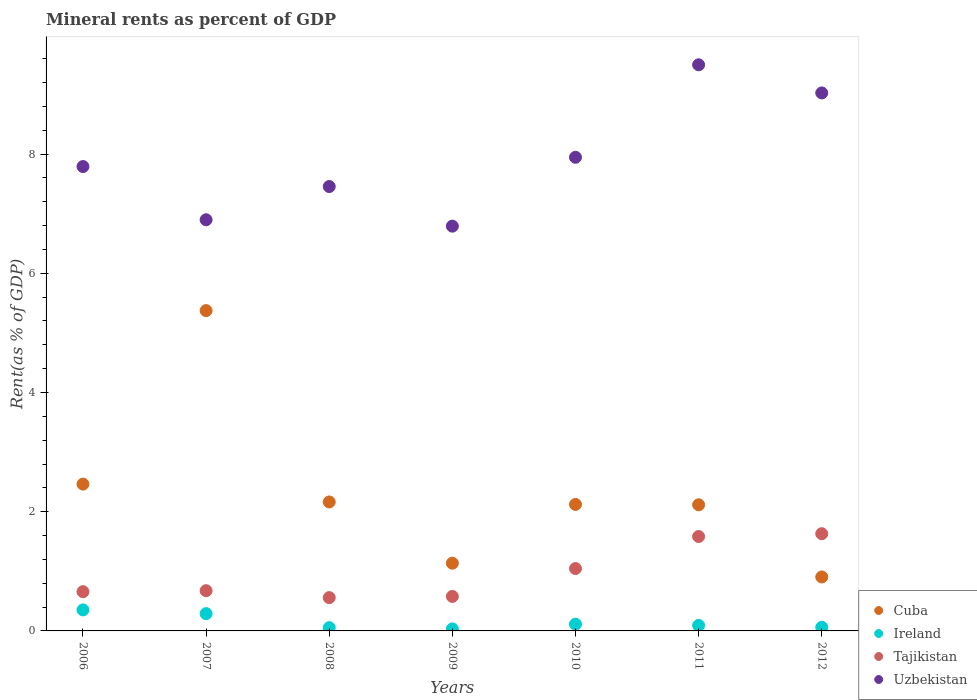What is the mineral rent in Tajikistan in 2006?
Your answer should be very brief. 0.66. Across all years, what is the maximum mineral rent in Uzbekistan?
Keep it short and to the point. 9.5. Across all years, what is the minimum mineral rent in Cuba?
Offer a terse response. 0.91. In which year was the mineral rent in Ireland minimum?
Offer a very short reply. 2009. What is the total mineral rent in Ireland in the graph?
Your answer should be very brief. 1. What is the difference between the mineral rent in Uzbekistan in 2010 and that in 2012?
Ensure brevity in your answer.  -1.08. What is the difference between the mineral rent in Uzbekistan in 2006 and the mineral rent in Cuba in 2010?
Your response must be concise. 5.67. What is the average mineral rent in Cuba per year?
Ensure brevity in your answer.  2.33. In the year 2009, what is the difference between the mineral rent in Ireland and mineral rent in Uzbekistan?
Your answer should be very brief. -6.76. What is the ratio of the mineral rent in Uzbekistan in 2010 to that in 2012?
Keep it short and to the point. 0.88. Is the difference between the mineral rent in Ireland in 2006 and 2012 greater than the difference between the mineral rent in Uzbekistan in 2006 and 2012?
Your response must be concise. Yes. What is the difference between the highest and the second highest mineral rent in Uzbekistan?
Make the answer very short. 0.47. What is the difference between the highest and the lowest mineral rent in Ireland?
Keep it short and to the point. 0.32. Is the sum of the mineral rent in Uzbekistan in 2006 and 2007 greater than the maximum mineral rent in Cuba across all years?
Make the answer very short. Yes. Is it the case that in every year, the sum of the mineral rent in Ireland and mineral rent in Cuba  is greater than the sum of mineral rent in Tajikistan and mineral rent in Uzbekistan?
Make the answer very short. No. Is the mineral rent in Tajikistan strictly less than the mineral rent in Ireland over the years?
Ensure brevity in your answer.  No. How many years are there in the graph?
Your answer should be compact. 7. Are the values on the major ticks of Y-axis written in scientific E-notation?
Your answer should be compact. No. Does the graph contain grids?
Give a very brief answer. No. What is the title of the graph?
Your response must be concise. Mineral rents as percent of GDP. Does "South Africa" appear as one of the legend labels in the graph?
Give a very brief answer. No. What is the label or title of the Y-axis?
Offer a terse response. Rent(as % of GDP). What is the Rent(as % of GDP) of Cuba in 2006?
Give a very brief answer. 2.46. What is the Rent(as % of GDP) of Ireland in 2006?
Keep it short and to the point. 0.35. What is the Rent(as % of GDP) in Tajikistan in 2006?
Keep it short and to the point. 0.66. What is the Rent(as % of GDP) in Uzbekistan in 2006?
Offer a very short reply. 7.79. What is the Rent(as % of GDP) of Cuba in 2007?
Give a very brief answer. 5.37. What is the Rent(as % of GDP) of Ireland in 2007?
Provide a succinct answer. 0.29. What is the Rent(as % of GDP) of Tajikistan in 2007?
Make the answer very short. 0.67. What is the Rent(as % of GDP) of Uzbekistan in 2007?
Provide a short and direct response. 6.9. What is the Rent(as % of GDP) of Cuba in 2008?
Make the answer very short. 2.16. What is the Rent(as % of GDP) of Ireland in 2008?
Make the answer very short. 0.05. What is the Rent(as % of GDP) of Tajikistan in 2008?
Offer a terse response. 0.56. What is the Rent(as % of GDP) of Uzbekistan in 2008?
Provide a succinct answer. 7.45. What is the Rent(as % of GDP) in Cuba in 2009?
Keep it short and to the point. 1.14. What is the Rent(as % of GDP) of Ireland in 2009?
Make the answer very short. 0.03. What is the Rent(as % of GDP) in Tajikistan in 2009?
Your response must be concise. 0.58. What is the Rent(as % of GDP) in Uzbekistan in 2009?
Provide a succinct answer. 6.79. What is the Rent(as % of GDP) of Cuba in 2010?
Make the answer very short. 2.12. What is the Rent(as % of GDP) of Ireland in 2010?
Your answer should be very brief. 0.11. What is the Rent(as % of GDP) in Tajikistan in 2010?
Provide a short and direct response. 1.05. What is the Rent(as % of GDP) in Uzbekistan in 2010?
Your response must be concise. 7.95. What is the Rent(as % of GDP) in Cuba in 2011?
Your answer should be very brief. 2.12. What is the Rent(as % of GDP) of Ireland in 2011?
Your answer should be very brief. 0.09. What is the Rent(as % of GDP) in Tajikistan in 2011?
Give a very brief answer. 1.58. What is the Rent(as % of GDP) of Uzbekistan in 2011?
Ensure brevity in your answer.  9.5. What is the Rent(as % of GDP) of Cuba in 2012?
Offer a terse response. 0.91. What is the Rent(as % of GDP) of Ireland in 2012?
Give a very brief answer. 0.06. What is the Rent(as % of GDP) of Tajikistan in 2012?
Offer a terse response. 1.63. What is the Rent(as % of GDP) of Uzbekistan in 2012?
Your answer should be compact. 9.03. Across all years, what is the maximum Rent(as % of GDP) in Cuba?
Keep it short and to the point. 5.37. Across all years, what is the maximum Rent(as % of GDP) of Ireland?
Your answer should be compact. 0.35. Across all years, what is the maximum Rent(as % of GDP) of Tajikistan?
Your answer should be compact. 1.63. Across all years, what is the maximum Rent(as % of GDP) in Uzbekistan?
Ensure brevity in your answer.  9.5. Across all years, what is the minimum Rent(as % of GDP) in Cuba?
Offer a very short reply. 0.91. Across all years, what is the minimum Rent(as % of GDP) of Ireland?
Make the answer very short. 0.03. Across all years, what is the minimum Rent(as % of GDP) in Tajikistan?
Your answer should be compact. 0.56. Across all years, what is the minimum Rent(as % of GDP) in Uzbekistan?
Make the answer very short. 6.79. What is the total Rent(as % of GDP) in Cuba in the graph?
Ensure brevity in your answer.  16.28. What is the total Rent(as % of GDP) in Tajikistan in the graph?
Ensure brevity in your answer.  6.73. What is the total Rent(as % of GDP) in Uzbekistan in the graph?
Ensure brevity in your answer.  55.4. What is the difference between the Rent(as % of GDP) of Cuba in 2006 and that in 2007?
Make the answer very short. -2.91. What is the difference between the Rent(as % of GDP) in Ireland in 2006 and that in 2007?
Offer a very short reply. 0.06. What is the difference between the Rent(as % of GDP) in Tajikistan in 2006 and that in 2007?
Provide a succinct answer. -0.02. What is the difference between the Rent(as % of GDP) in Uzbekistan in 2006 and that in 2007?
Your answer should be very brief. 0.89. What is the difference between the Rent(as % of GDP) of Cuba in 2006 and that in 2008?
Your response must be concise. 0.3. What is the difference between the Rent(as % of GDP) of Ireland in 2006 and that in 2008?
Offer a terse response. 0.3. What is the difference between the Rent(as % of GDP) in Tajikistan in 2006 and that in 2008?
Make the answer very short. 0.1. What is the difference between the Rent(as % of GDP) of Uzbekistan in 2006 and that in 2008?
Your answer should be compact. 0.34. What is the difference between the Rent(as % of GDP) in Cuba in 2006 and that in 2009?
Offer a terse response. 1.33. What is the difference between the Rent(as % of GDP) in Ireland in 2006 and that in 2009?
Your answer should be very brief. 0.32. What is the difference between the Rent(as % of GDP) of Tajikistan in 2006 and that in 2009?
Your answer should be very brief. 0.08. What is the difference between the Rent(as % of GDP) in Cuba in 2006 and that in 2010?
Provide a succinct answer. 0.34. What is the difference between the Rent(as % of GDP) in Ireland in 2006 and that in 2010?
Keep it short and to the point. 0.24. What is the difference between the Rent(as % of GDP) in Tajikistan in 2006 and that in 2010?
Keep it short and to the point. -0.39. What is the difference between the Rent(as % of GDP) of Uzbekistan in 2006 and that in 2010?
Make the answer very short. -0.16. What is the difference between the Rent(as % of GDP) of Cuba in 2006 and that in 2011?
Your response must be concise. 0.35. What is the difference between the Rent(as % of GDP) in Ireland in 2006 and that in 2011?
Provide a succinct answer. 0.26. What is the difference between the Rent(as % of GDP) of Tajikistan in 2006 and that in 2011?
Offer a terse response. -0.93. What is the difference between the Rent(as % of GDP) in Uzbekistan in 2006 and that in 2011?
Offer a terse response. -1.71. What is the difference between the Rent(as % of GDP) in Cuba in 2006 and that in 2012?
Your answer should be compact. 1.56. What is the difference between the Rent(as % of GDP) in Ireland in 2006 and that in 2012?
Your answer should be very brief. 0.29. What is the difference between the Rent(as % of GDP) in Tajikistan in 2006 and that in 2012?
Keep it short and to the point. -0.97. What is the difference between the Rent(as % of GDP) of Uzbekistan in 2006 and that in 2012?
Your answer should be very brief. -1.23. What is the difference between the Rent(as % of GDP) in Cuba in 2007 and that in 2008?
Offer a terse response. 3.21. What is the difference between the Rent(as % of GDP) of Ireland in 2007 and that in 2008?
Provide a short and direct response. 0.24. What is the difference between the Rent(as % of GDP) in Tajikistan in 2007 and that in 2008?
Make the answer very short. 0.12. What is the difference between the Rent(as % of GDP) in Uzbekistan in 2007 and that in 2008?
Ensure brevity in your answer.  -0.56. What is the difference between the Rent(as % of GDP) in Cuba in 2007 and that in 2009?
Provide a short and direct response. 4.24. What is the difference between the Rent(as % of GDP) in Ireland in 2007 and that in 2009?
Your answer should be compact. 0.26. What is the difference between the Rent(as % of GDP) of Tajikistan in 2007 and that in 2009?
Provide a succinct answer. 0.1. What is the difference between the Rent(as % of GDP) in Uzbekistan in 2007 and that in 2009?
Offer a terse response. 0.11. What is the difference between the Rent(as % of GDP) of Cuba in 2007 and that in 2010?
Your answer should be compact. 3.25. What is the difference between the Rent(as % of GDP) in Ireland in 2007 and that in 2010?
Provide a succinct answer. 0.18. What is the difference between the Rent(as % of GDP) in Tajikistan in 2007 and that in 2010?
Your response must be concise. -0.37. What is the difference between the Rent(as % of GDP) of Uzbekistan in 2007 and that in 2010?
Keep it short and to the point. -1.05. What is the difference between the Rent(as % of GDP) in Cuba in 2007 and that in 2011?
Ensure brevity in your answer.  3.26. What is the difference between the Rent(as % of GDP) of Ireland in 2007 and that in 2011?
Provide a short and direct response. 0.2. What is the difference between the Rent(as % of GDP) in Tajikistan in 2007 and that in 2011?
Your response must be concise. -0.91. What is the difference between the Rent(as % of GDP) of Uzbekistan in 2007 and that in 2011?
Provide a succinct answer. -2.6. What is the difference between the Rent(as % of GDP) in Cuba in 2007 and that in 2012?
Offer a very short reply. 4.47. What is the difference between the Rent(as % of GDP) of Ireland in 2007 and that in 2012?
Provide a short and direct response. 0.23. What is the difference between the Rent(as % of GDP) in Tajikistan in 2007 and that in 2012?
Keep it short and to the point. -0.96. What is the difference between the Rent(as % of GDP) of Uzbekistan in 2007 and that in 2012?
Your answer should be very brief. -2.13. What is the difference between the Rent(as % of GDP) in Cuba in 2008 and that in 2009?
Provide a short and direct response. 1.03. What is the difference between the Rent(as % of GDP) of Ireland in 2008 and that in 2009?
Offer a very short reply. 0.02. What is the difference between the Rent(as % of GDP) of Tajikistan in 2008 and that in 2009?
Provide a short and direct response. -0.02. What is the difference between the Rent(as % of GDP) of Uzbekistan in 2008 and that in 2009?
Offer a terse response. 0.66. What is the difference between the Rent(as % of GDP) in Cuba in 2008 and that in 2010?
Offer a very short reply. 0.04. What is the difference between the Rent(as % of GDP) of Ireland in 2008 and that in 2010?
Offer a very short reply. -0.06. What is the difference between the Rent(as % of GDP) of Tajikistan in 2008 and that in 2010?
Ensure brevity in your answer.  -0.49. What is the difference between the Rent(as % of GDP) of Uzbekistan in 2008 and that in 2010?
Your answer should be very brief. -0.49. What is the difference between the Rent(as % of GDP) in Cuba in 2008 and that in 2011?
Your answer should be very brief. 0.05. What is the difference between the Rent(as % of GDP) of Ireland in 2008 and that in 2011?
Your response must be concise. -0.04. What is the difference between the Rent(as % of GDP) in Tajikistan in 2008 and that in 2011?
Provide a short and direct response. -1.03. What is the difference between the Rent(as % of GDP) of Uzbekistan in 2008 and that in 2011?
Offer a terse response. -2.04. What is the difference between the Rent(as % of GDP) of Cuba in 2008 and that in 2012?
Your answer should be very brief. 1.26. What is the difference between the Rent(as % of GDP) in Ireland in 2008 and that in 2012?
Keep it short and to the point. -0.01. What is the difference between the Rent(as % of GDP) in Tajikistan in 2008 and that in 2012?
Provide a short and direct response. -1.07. What is the difference between the Rent(as % of GDP) of Uzbekistan in 2008 and that in 2012?
Offer a terse response. -1.57. What is the difference between the Rent(as % of GDP) in Cuba in 2009 and that in 2010?
Offer a terse response. -0.99. What is the difference between the Rent(as % of GDP) in Ireland in 2009 and that in 2010?
Offer a very short reply. -0.08. What is the difference between the Rent(as % of GDP) in Tajikistan in 2009 and that in 2010?
Make the answer very short. -0.47. What is the difference between the Rent(as % of GDP) in Uzbekistan in 2009 and that in 2010?
Ensure brevity in your answer.  -1.16. What is the difference between the Rent(as % of GDP) in Cuba in 2009 and that in 2011?
Provide a short and direct response. -0.98. What is the difference between the Rent(as % of GDP) in Ireland in 2009 and that in 2011?
Offer a terse response. -0.06. What is the difference between the Rent(as % of GDP) in Tajikistan in 2009 and that in 2011?
Your answer should be compact. -1.01. What is the difference between the Rent(as % of GDP) of Uzbekistan in 2009 and that in 2011?
Give a very brief answer. -2.71. What is the difference between the Rent(as % of GDP) of Cuba in 2009 and that in 2012?
Make the answer very short. 0.23. What is the difference between the Rent(as % of GDP) of Ireland in 2009 and that in 2012?
Keep it short and to the point. -0.03. What is the difference between the Rent(as % of GDP) in Tajikistan in 2009 and that in 2012?
Offer a very short reply. -1.05. What is the difference between the Rent(as % of GDP) in Uzbekistan in 2009 and that in 2012?
Provide a succinct answer. -2.23. What is the difference between the Rent(as % of GDP) of Cuba in 2010 and that in 2011?
Provide a succinct answer. 0.01. What is the difference between the Rent(as % of GDP) in Ireland in 2010 and that in 2011?
Provide a short and direct response. 0.02. What is the difference between the Rent(as % of GDP) of Tajikistan in 2010 and that in 2011?
Your answer should be very brief. -0.54. What is the difference between the Rent(as % of GDP) of Uzbekistan in 2010 and that in 2011?
Offer a very short reply. -1.55. What is the difference between the Rent(as % of GDP) of Cuba in 2010 and that in 2012?
Your answer should be compact. 1.22. What is the difference between the Rent(as % of GDP) in Ireland in 2010 and that in 2012?
Give a very brief answer. 0.05. What is the difference between the Rent(as % of GDP) of Tajikistan in 2010 and that in 2012?
Offer a very short reply. -0.58. What is the difference between the Rent(as % of GDP) in Uzbekistan in 2010 and that in 2012?
Make the answer very short. -1.08. What is the difference between the Rent(as % of GDP) in Cuba in 2011 and that in 2012?
Make the answer very short. 1.21. What is the difference between the Rent(as % of GDP) of Ireland in 2011 and that in 2012?
Provide a succinct answer. 0.03. What is the difference between the Rent(as % of GDP) of Tajikistan in 2011 and that in 2012?
Offer a terse response. -0.05. What is the difference between the Rent(as % of GDP) in Uzbekistan in 2011 and that in 2012?
Ensure brevity in your answer.  0.47. What is the difference between the Rent(as % of GDP) of Cuba in 2006 and the Rent(as % of GDP) of Ireland in 2007?
Your response must be concise. 2.17. What is the difference between the Rent(as % of GDP) of Cuba in 2006 and the Rent(as % of GDP) of Tajikistan in 2007?
Give a very brief answer. 1.79. What is the difference between the Rent(as % of GDP) of Cuba in 2006 and the Rent(as % of GDP) of Uzbekistan in 2007?
Offer a terse response. -4.43. What is the difference between the Rent(as % of GDP) of Ireland in 2006 and the Rent(as % of GDP) of Tajikistan in 2007?
Make the answer very short. -0.32. What is the difference between the Rent(as % of GDP) of Ireland in 2006 and the Rent(as % of GDP) of Uzbekistan in 2007?
Offer a terse response. -6.55. What is the difference between the Rent(as % of GDP) of Tajikistan in 2006 and the Rent(as % of GDP) of Uzbekistan in 2007?
Provide a short and direct response. -6.24. What is the difference between the Rent(as % of GDP) of Cuba in 2006 and the Rent(as % of GDP) of Ireland in 2008?
Your response must be concise. 2.41. What is the difference between the Rent(as % of GDP) in Cuba in 2006 and the Rent(as % of GDP) in Tajikistan in 2008?
Keep it short and to the point. 1.9. What is the difference between the Rent(as % of GDP) in Cuba in 2006 and the Rent(as % of GDP) in Uzbekistan in 2008?
Your answer should be compact. -4.99. What is the difference between the Rent(as % of GDP) of Ireland in 2006 and the Rent(as % of GDP) of Tajikistan in 2008?
Ensure brevity in your answer.  -0.21. What is the difference between the Rent(as % of GDP) in Ireland in 2006 and the Rent(as % of GDP) in Uzbekistan in 2008?
Your response must be concise. -7.1. What is the difference between the Rent(as % of GDP) in Tajikistan in 2006 and the Rent(as % of GDP) in Uzbekistan in 2008?
Your answer should be compact. -6.8. What is the difference between the Rent(as % of GDP) in Cuba in 2006 and the Rent(as % of GDP) in Ireland in 2009?
Ensure brevity in your answer.  2.43. What is the difference between the Rent(as % of GDP) in Cuba in 2006 and the Rent(as % of GDP) in Tajikistan in 2009?
Keep it short and to the point. 1.88. What is the difference between the Rent(as % of GDP) of Cuba in 2006 and the Rent(as % of GDP) of Uzbekistan in 2009?
Your answer should be compact. -4.33. What is the difference between the Rent(as % of GDP) of Ireland in 2006 and the Rent(as % of GDP) of Tajikistan in 2009?
Offer a very short reply. -0.23. What is the difference between the Rent(as % of GDP) of Ireland in 2006 and the Rent(as % of GDP) of Uzbekistan in 2009?
Keep it short and to the point. -6.44. What is the difference between the Rent(as % of GDP) in Tajikistan in 2006 and the Rent(as % of GDP) in Uzbekistan in 2009?
Your response must be concise. -6.13. What is the difference between the Rent(as % of GDP) in Cuba in 2006 and the Rent(as % of GDP) in Ireland in 2010?
Your response must be concise. 2.35. What is the difference between the Rent(as % of GDP) in Cuba in 2006 and the Rent(as % of GDP) in Tajikistan in 2010?
Give a very brief answer. 1.42. What is the difference between the Rent(as % of GDP) in Cuba in 2006 and the Rent(as % of GDP) in Uzbekistan in 2010?
Offer a terse response. -5.48. What is the difference between the Rent(as % of GDP) in Ireland in 2006 and the Rent(as % of GDP) in Tajikistan in 2010?
Your answer should be compact. -0.69. What is the difference between the Rent(as % of GDP) of Ireland in 2006 and the Rent(as % of GDP) of Uzbekistan in 2010?
Your answer should be very brief. -7.59. What is the difference between the Rent(as % of GDP) of Tajikistan in 2006 and the Rent(as % of GDP) of Uzbekistan in 2010?
Your answer should be very brief. -7.29. What is the difference between the Rent(as % of GDP) of Cuba in 2006 and the Rent(as % of GDP) of Ireland in 2011?
Provide a short and direct response. 2.37. What is the difference between the Rent(as % of GDP) of Cuba in 2006 and the Rent(as % of GDP) of Tajikistan in 2011?
Offer a very short reply. 0.88. What is the difference between the Rent(as % of GDP) of Cuba in 2006 and the Rent(as % of GDP) of Uzbekistan in 2011?
Your answer should be compact. -7.03. What is the difference between the Rent(as % of GDP) in Ireland in 2006 and the Rent(as % of GDP) in Tajikistan in 2011?
Ensure brevity in your answer.  -1.23. What is the difference between the Rent(as % of GDP) in Ireland in 2006 and the Rent(as % of GDP) in Uzbekistan in 2011?
Your answer should be compact. -9.14. What is the difference between the Rent(as % of GDP) of Tajikistan in 2006 and the Rent(as % of GDP) of Uzbekistan in 2011?
Your answer should be very brief. -8.84. What is the difference between the Rent(as % of GDP) of Cuba in 2006 and the Rent(as % of GDP) of Ireland in 2012?
Provide a short and direct response. 2.4. What is the difference between the Rent(as % of GDP) of Cuba in 2006 and the Rent(as % of GDP) of Tajikistan in 2012?
Your answer should be compact. 0.83. What is the difference between the Rent(as % of GDP) of Cuba in 2006 and the Rent(as % of GDP) of Uzbekistan in 2012?
Ensure brevity in your answer.  -6.56. What is the difference between the Rent(as % of GDP) of Ireland in 2006 and the Rent(as % of GDP) of Tajikistan in 2012?
Ensure brevity in your answer.  -1.28. What is the difference between the Rent(as % of GDP) of Ireland in 2006 and the Rent(as % of GDP) of Uzbekistan in 2012?
Provide a short and direct response. -8.67. What is the difference between the Rent(as % of GDP) in Tajikistan in 2006 and the Rent(as % of GDP) in Uzbekistan in 2012?
Your response must be concise. -8.37. What is the difference between the Rent(as % of GDP) of Cuba in 2007 and the Rent(as % of GDP) of Ireland in 2008?
Provide a succinct answer. 5.32. What is the difference between the Rent(as % of GDP) in Cuba in 2007 and the Rent(as % of GDP) in Tajikistan in 2008?
Offer a terse response. 4.81. What is the difference between the Rent(as % of GDP) in Cuba in 2007 and the Rent(as % of GDP) in Uzbekistan in 2008?
Keep it short and to the point. -2.08. What is the difference between the Rent(as % of GDP) of Ireland in 2007 and the Rent(as % of GDP) of Tajikistan in 2008?
Your answer should be compact. -0.27. What is the difference between the Rent(as % of GDP) in Ireland in 2007 and the Rent(as % of GDP) in Uzbekistan in 2008?
Make the answer very short. -7.16. What is the difference between the Rent(as % of GDP) in Tajikistan in 2007 and the Rent(as % of GDP) in Uzbekistan in 2008?
Provide a short and direct response. -6.78. What is the difference between the Rent(as % of GDP) in Cuba in 2007 and the Rent(as % of GDP) in Ireland in 2009?
Provide a succinct answer. 5.34. What is the difference between the Rent(as % of GDP) in Cuba in 2007 and the Rent(as % of GDP) in Tajikistan in 2009?
Provide a succinct answer. 4.79. What is the difference between the Rent(as % of GDP) in Cuba in 2007 and the Rent(as % of GDP) in Uzbekistan in 2009?
Your answer should be very brief. -1.42. What is the difference between the Rent(as % of GDP) of Ireland in 2007 and the Rent(as % of GDP) of Tajikistan in 2009?
Your answer should be very brief. -0.29. What is the difference between the Rent(as % of GDP) of Tajikistan in 2007 and the Rent(as % of GDP) of Uzbekistan in 2009?
Your response must be concise. -6.12. What is the difference between the Rent(as % of GDP) in Cuba in 2007 and the Rent(as % of GDP) in Ireland in 2010?
Ensure brevity in your answer.  5.26. What is the difference between the Rent(as % of GDP) of Cuba in 2007 and the Rent(as % of GDP) of Tajikistan in 2010?
Your response must be concise. 4.33. What is the difference between the Rent(as % of GDP) in Cuba in 2007 and the Rent(as % of GDP) in Uzbekistan in 2010?
Your answer should be very brief. -2.57. What is the difference between the Rent(as % of GDP) of Ireland in 2007 and the Rent(as % of GDP) of Tajikistan in 2010?
Give a very brief answer. -0.76. What is the difference between the Rent(as % of GDP) of Ireland in 2007 and the Rent(as % of GDP) of Uzbekistan in 2010?
Provide a succinct answer. -7.66. What is the difference between the Rent(as % of GDP) in Tajikistan in 2007 and the Rent(as % of GDP) in Uzbekistan in 2010?
Your response must be concise. -7.27. What is the difference between the Rent(as % of GDP) of Cuba in 2007 and the Rent(as % of GDP) of Ireland in 2011?
Provide a succinct answer. 5.28. What is the difference between the Rent(as % of GDP) of Cuba in 2007 and the Rent(as % of GDP) of Tajikistan in 2011?
Offer a very short reply. 3.79. What is the difference between the Rent(as % of GDP) in Cuba in 2007 and the Rent(as % of GDP) in Uzbekistan in 2011?
Provide a succinct answer. -4.12. What is the difference between the Rent(as % of GDP) of Ireland in 2007 and the Rent(as % of GDP) of Tajikistan in 2011?
Provide a short and direct response. -1.29. What is the difference between the Rent(as % of GDP) in Ireland in 2007 and the Rent(as % of GDP) in Uzbekistan in 2011?
Your answer should be compact. -9.21. What is the difference between the Rent(as % of GDP) in Tajikistan in 2007 and the Rent(as % of GDP) in Uzbekistan in 2011?
Provide a succinct answer. -8.82. What is the difference between the Rent(as % of GDP) in Cuba in 2007 and the Rent(as % of GDP) in Ireland in 2012?
Offer a terse response. 5.31. What is the difference between the Rent(as % of GDP) of Cuba in 2007 and the Rent(as % of GDP) of Tajikistan in 2012?
Offer a very short reply. 3.74. What is the difference between the Rent(as % of GDP) of Cuba in 2007 and the Rent(as % of GDP) of Uzbekistan in 2012?
Provide a short and direct response. -3.65. What is the difference between the Rent(as % of GDP) of Ireland in 2007 and the Rent(as % of GDP) of Tajikistan in 2012?
Provide a short and direct response. -1.34. What is the difference between the Rent(as % of GDP) in Ireland in 2007 and the Rent(as % of GDP) in Uzbekistan in 2012?
Give a very brief answer. -8.73. What is the difference between the Rent(as % of GDP) of Tajikistan in 2007 and the Rent(as % of GDP) of Uzbekistan in 2012?
Your response must be concise. -8.35. What is the difference between the Rent(as % of GDP) of Cuba in 2008 and the Rent(as % of GDP) of Ireland in 2009?
Your answer should be compact. 2.13. What is the difference between the Rent(as % of GDP) in Cuba in 2008 and the Rent(as % of GDP) in Tajikistan in 2009?
Your answer should be compact. 1.58. What is the difference between the Rent(as % of GDP) of Cuba in 2008 and the Rent(as % of GDP) of Uzbekistan in 2009?
Your answer should be compact. -4.63. What is the difference between the Rent(as % of GDP) of Ireland in 2008 and the Rent(as % of GDP) of Tajikistan in 2009?
Keep it short and to the point. -0.52. What is the difference between the Rent(as % of GDP) of Ireland in 2008 and the Rent(as % of GDP) of Uzbekistan in 2009?
Provide a short and direct response. -6.74. What is the difference between the Rent(as % of GDP) of Tajikistan in 2008 and the Rent(as % of GDP) of Uzbekistan in 2009?
Your answer should be compact. -6.23. What is the difference between the Rent(as % of GDP) in Cuba in 2008 and the Rent(as % of GDP) in Ireland in 2010?
Offer a terse response. 2.05. What is the difference between the Rent(as % of GDP) of Cuba in 2008 and the Rent(as % of GDP) of Tajikistan in 2010?
Offer a terse response. 1.12. What is the difference between the Rent(as % of GDP) of Cuba in 2008 and the Rent(as % of GDP) of Uzbekistan in 2010?
Give a very brief answer. -5.78. What is the difference between the Rent(as % of GDP) of Ireland in 2008 and the Rent(as % of GDP) of Tajikistan in 2010?
Your answer should be very brief. -0.99. What is the difference between the Rent(as % of GDP) of Ireland in 2008 and the Rent(as % of GDP) of Uzbekistan in 2010?
Provide a succinct answer. -7.89. What is the difference between the Rent(as % of GDP) of Tajikistan in 2008 and the Rent(as % of GDP) of Uzbekistan in 2010?
Your answer should be very brief. -7.39. What is the difference between the Rent(as % of GDP) of Cuba in 2008 and the Rent(as % of GDP) of Ireland in 2011?
Give a very brief answer. 2.07. What is the difference between the Rent(as % of GDP) in Cuba in 2008 and the Rent(as % of GDP) in Tajikistan in 2011?
Give a very brief answer. 0.58. What is the difference between the Rent(as % of GDP) of Cuba in 2008 and the Rent(as % of GDP) of Uzbekistan in 2011?
Your response must be concise. -7.33. What is the difference between the Rent(as % of GDP) of Ireland in 2008 and the Rent(as % of GDP) of Tajikistan in 2011?
Make the answer very short. -1.53. What is the difference between the Rent(as % of GDP) in Ireland in 2008 and the Rent(as % of GDP) in Uzbekistan in 2011?
Your answer should be very brief. -9.44. What is the difference between the Rent(as % of GDP) in Tajikistan in 2008 and the Rent(as % of GDP) in Uzbekistan in 2011?
Make the answer very short. -8.94. What is the difference between the Rent(as % of GDP) in Cuba in 2008 and the Rent(as % of GDP) in Ireland in 2012?
Your answer should be very brief. 2.1. What is the difference between the Rent(as % of GDP) of Cuba in 2008 and the Rent(as % of GDP) of Tajikistan in 2012?
Ensure brevity in your answer.  0.53. What is the difference between the Rent(as % of GDP) of Cuba in 2008 and the Rent(as % of GDP) of Uzbekistan in 2012?
Give a very brief answer. -6.86. What is the difference between the Rent(as % of GDP) of Ireland in 2008 and the Rent(as % of GDP) of Tajikistan in 2012?
Keep it short and to the point. -1.58. What is the difference between the Rent(as % of GDP) in Ireland in 2008 and the Rent(as % of GDP) in Uzbekistan in 2012?
Provide a succinct answer. -8.97. What is the difference between the Rent(as % of GDP) in Tajikistan in 2008 and the Rent(as % of GDP) in Uzbekistan in 2012?
Keep it short and to the point. -8.47. What is the difference between the Rent(as % of GDP) of Cuba in 2009 and the Rent(as % of GDP) of Ireland in 2010?
Your answer should be compact. 1.02. What is the difference between the Rent(as % of GDP) in Cuba in 2009 and the Rent(as % of GDP) in Tajikistan in 2010?
Your response must be concise. 0.09. What is the difference between the Rent(as % of GDP) of Cuba in 2009 and the Rent(as % of GDP) of Uzbekistan in 2010?
Make the answer very short. -6.81. What is the difference between the Rent(as % of GDP) in Ireland in 2009 and the Rent(as % of GDP) in Tajikistan in 2010?
Ensure brevity in your answer.  -1.01. What is the difference between the Rent(as % of GDP) of Ireland in 2009 and the Rent(as % of GDP) of Uzbekistan in 2010?
Give a very brief answer. -7.91. What is the difference between the Rent(as % of GDP) in Tajikistan in 2009 and the Rent(as % of GDP) in Uzbekistan in 2010?
Keep it short and to the point. -7.37. What is the difference between the Rent(as % of GDP) of Cuba in 2009 and the Rent(as % of GDP) of Ireland in 2011?
Ensure brevity in your answer.  1.04. What is the difference between the Rent(as % of GDP) in Cuba in 2009 and the Rent(as % of GDP) in Tajikistan in 2011?
Keep it short and to the point. -0.45. What is the difference between the Rent(as % of GDP) of Cuba in 2009 and the Rent(as % of GDP) of Uzbekistan in 2011?
Your answer should be very brief. -8.36. What is the difference between the Rent(as % of GDP) in Ireland in 2009 and the Rent(as % of GDP) in Tajikistan in 2011?
Offer a terse response. -1.55. What is the difference between the Rent(as % of GDP) in Ireland in 2009 and the Rent(as % of GDP) in Uzbekistan in 2011?
Ensure brevity in your answer.  -9.46. What is the difference between the Rent(as % of GDP) in Tajikistan in 2009 and the Rent(as % of GDP) in Uzbekistan in 2011?
Provide a succinct answer. -8.92. What is the difference between the Rent(as % of GDP) in Cuba in 2009 and the Rent(as % of GDP) in Ireland in 2012?
Provide a succinct answer. 1.08. What is the difference between the Rent(as % of GDP) of Cuba in 2009 and the Rent(as % of GDP) of Tajikistan in 2012?
Your response must be concise. -0.49. What is the difference between the Rent(as % of GDP) of Cuba in 2009 and the Rent(as % of GDP) of Uzbekistan in 2012?
Ensure brevity in your answer.  -7.89. What is the difference between the Rent(as % of GDP) in Ireland in 2009 and the Rent(as % of GDP) in Tajikistan in 2012?
Your response must be concise. -1.6. What is the difference between the Rent(as % of GDP) in Ireland in 2009 and the Rent(as % of GDP) in Uzbekistan in 2012?
Provide a succinct answer. -8.99. What is the difference between the Rent(as % of GDP) in Tajikistan in 2009 and the Rent(as % of GDP) in Uzbekistan in 2012?
Provide a succinct answer. -8.45. What is the difference between the Rent(as % of GDP) of Cuba in 2010 and the Rent(as % of GDP) of Ireland in 2011?
Give a very brief answer. 2.03. What is the difference between the Rent(as % of GDP) in Cuba in 2010 and the Rent(as % of GDP) in Tajikistan in 2011?
Make the answer very short. 0.54. What is the difference between the Rent(as % of GDP) of Cuba in 2010 and the Rent(as % of GDP) of Uzbekistan in 2011?
Offer a very short reply. -7.38. What is the difference between the Rent(as % of GDP) in Ireland in 2010 and the Rent(as % of GDP) in Tajikistan in 2011?
Give a very brief answer. -1.47. What is the difference between the Rent(as % of GDP) of Ireland in 2010 and the Rent(as % of GDP) of Uzbekistan in 2011?
Make the answer very short. -9.38. What is the difference between the Rent(as % of GDP) in Tajikistan in 2010 and the Rent(as % of GDP) in Uzbekistan in 2011?
Your answer should be compact. -8.45. What is the difference between the Rent(as % of GDP) of Cuba in 2010 and the Rent(as % of GDP) of Ireland in 2012?
Keep it short and to the point. 2.06. What is the difference between the Rent(as % of GDP) in Cuba in 2010 and the Rent(as % of GDP) in Tajikistan in 2012?
Offer a terse response. 0.49. What is the difference between the Rent(as % of GDP) of Cuba in 2010 and the Rent(as % of GDP) of Uzbekistan in 2012?
Your response must be concise. -6.9. What is the difference between the Rent(as % of GDP) in Ireland in 2010 and the Rent(as % of GDP) in Tajikistan in 2012?
Give a very brief answer. -1.52. What is the difference between the Rent(as % of GDP) of Ireland in 2010 and the Rent(as % of GDP) of Uzbekistan in 2012?
Your response must be concise. -8.91. What is the difference between the Rent(as % of GDP) of Tajikistan in 2010 and the Rent(as % of GDP) of Uzbekistan in 2012?
Offer a terse response. -7.98. What is the difference between the Rent(as % of GDP) in Cuba in 2011 and the Rent(as % of GDP) in Ireland in 2012?
Provide a succinct answer. 2.06. What is the difference between the Rent(as % of GDP) of Cuba in 2011 and the Rent(as % of GDP) of Tajikistan in 2012?
Your answer should be very brief. 0.49. What is the difference between the Rent(as % of GDP) in Cuba in 2011 and the Rent(as % of GDP) in Uzbekistan in 2012?
Provide a short and direct response. -6.91. What is the difference between the Rent(as % of GDP) in Ireland in 2011 and the Rent(as % of GDP) in Tajikistan in 2012?
Ensure brevity in your answer.  -1.54. What is the difference between the Rent(as % of GDP) of Ireland in 2011 and the Rent(as % of GDP) of Uzbekistan in 2012?
Your answer should be compact. -8.93. What is the difference between the Rent(as % of GDP) in Tajikistan in 2011 and the Rent(as % of GDP) in Uzbekistan in 2012?
Your answer should be compact. -7.44. What is the average Rent(as % of GDP) of Cuba per year?
Your answer should be very brief. 2.33. What is the average Rent(as % of GDP) in Ireland per year?
Give a very brief answer. 0.14. What is the average Rent(as % of GDP) in Tajikistan per year?
Offer a very short reply. 0.96. What is the average Rent(as % of GDP) in Uzbekistan per year?
Your answer should be compact. 7.91. In the year 2006, what is the difference between the Rent(as % of GDP) in Cuba and Rent(as % of GDP) in Ireland?
Provide a short and direct response. 2.11. In the year 2006, what is the difference between the Rent(as % of GDP) of Cuba and Rent(as % of GDP) of Tajikistan?
Keep it short and to the point. 1.8. In the year 2006, what is the difference between the Rent(as % of GDP) in Cuba and Rent(as % of GDP) in Uzbekistan?
Provide a short and direct response. -5.33. In the year 2006, what is the difference between the Rent(as % of GDP) in Ireland and Rent(as % of GDP) in Tajikistan?
Your answer should be compact. -0.31. In the year 2006, what is the difference between the Rent(as % of GDP) of Ireland and Rent(as % of GDP) of Uzbekistan?
Ensure brevity in your answer.  -7.44. In the year 2006, what is the difference between the Rent(as % of GDP) in Tajikistan and Rent(as % of GDP) in Uzbekistan?
Ensure brevity in your answer.  -7.13. In the year 2007, what is the difference between the Rent(as % of GDP) in Cuba and Rent(as % of GDP) in Ireland?
Provide a short and direct response. 5.08. In the year 2007, what is the difference between the Rent(as % of GDP) in Cuba and Rent(as % of GDP) in Tajikistan?
Provide a succinct answer. 4.7. In the year 2007, what is the difference between the Rent(as % of GDP) in Cuba and Rent(as % of GDP) in Uzbekistan?
Provide a succinct answer. -1.52. In the year 2007, what is the difference between the Rent(as % of GDP) in Ireland and Rent(as % of GDP) in Tajikistan?
Provide a succinct answer. -0.38. In the year 2007, what is the difference between the Rent(as % of GDP) of Ireland and Rent(as % of GDP) of Uzbekistan?
Provide a succinct answer. -6.61. In the year 2007, what is the difference between the Rent(as % of GDP) in Tajikistan and Rent(as % of GDP) in Uzbekistan?
Provide a short and direct response. -6.22. In the year 2008, what is the difference between the Rent(as % of GDP) in Cuba and Rent(as % of GDP) in Ireland?
Your response must be concise. 2.11. In the year 2008, what is the difference between the Rent(as % of GDP) of Cuba and Rent(as % of GDP) of Tajikistan?
Your answer should be compact. 1.6. In the year 2008, what is the difference between the Rent(as % of GDP) in Cuba and Rent(as % of GDP) in Uzbekistan?
Make the answer very short. -5.29. In the year 2008, what is the difference between the Rent(as % of GDP) of Ireland and Rent(as % of GDP) of Tajikistan?
Your answer should be very brief. -0.5. In the year 2008, what is the difference between the Rent(as % of GDP) of Ireland and Rent(as % of GDP) of Uzbekistan?
Offer a terse response. -7.4. In the year 2008, what is the difference between the Rent(as % of GDP) in Tajikistan and Rent(as % of GDP) in Uzbekistan?
Provide a short and direct response. -6.9. In the year 2009, what is the difference between the Rent(as % of GDP) in Cuba and Rent(as % of GDP) in Ireland?
Your answer should be very brief. 1.1. In the year 2009, what is the difference between the Rent(as % of GDP) in Cuba and Rent(as % of GDP) in Tajikistan?
Keep it short and to the point. 0.56. In the year 2009, what is the difference between the Rent(as % of GDP) of Cuba and Rent(as % of GDP) of Uzbekistan?
Offer a very short reply. -5.65. In the year 2009, what is the difference between the Rent(as % of GDP) in Ireland and Rent(as % of GDP) in Tajikistan?
Give a very brief answer. -0.55. In the year 2009, what is the difference between the Rent(as % of GDP) of Ireland and Rent(as % of GDP) of Uzbekistan?
Ensure brevity in your answer.  -6.76. In the year 2009, what is the difference between the Rent(as % of GDP) in Tajikistan and Rent(as % of GDP) in Uzbekistan?
Your response must be concise. -6.21. In the year 2010, what is the difference between the Rent(as % of GDP) of Cuba and Rent(as % of GDP) of Ireland?
Your response must be concise. 2.01. In the year 2010, what is the difference between the Rent(as % of GDP) in Cuba and Rent(as % of GDP) in Tajikistan?
Give a very brief answer. 1.08. In the year 2010, what is the difference between the Rent(as % of GDP) in Cuba and Rent(as % of GDP) in Uzbekistan?
Your answer should be very brief. -5.82. In the year 2010, what is the difference between the Rent(as % of GDP) in Ireland and Rent(as % of GDP) in Tajikistan?
Offer a very short reply. -0.93. In the year 2010, what is the difference between the Rent(as % of GDP) of Ireland and Rent(as % of GDP) of Uzbekistan?
Your response must be concise. -7.83. In the year 2010, what is the difference between the Rent(as % of GDP) of Tajikistan and Rent(as % of GDP) of Uzbekistan?
Provide a short and direct response. -6.9. In the year 2011, what is the difference between the Rent(as % of GDP) in Cuba and Rent(as % of GDP) in Ireland?
Your response must be concise. 2.02. In the year 2011, what is the difference between the Rent(as % of GDP) of Cuba and Rent(as % of GDP) of Tajikistan?
Ensure brevity in your answer.  0.53. In the year 2011, what is the difference between the Rent(as % of GDP) in Cuba and Rent(as % of GDP) in Uzbekistan?
Your answer should be compact. -7.38. In the year 2011, what is the difference between the Rent(as % of GDP) in Ireland and Rent(as % of GDP) in Tajikistan?
Ensure brevity in your answer.  -1.49. In the year 2011, what is the difference between the Rent(as % of GDP) of Ireland and Rent(as % of GDP) of Uzbekistan?
Provide a succinct answer. -9.4. In the year 2011, what is the difference between the Rent(as % of GDP) of Tajikistan and Rent(as % of GDP) of Uzbekistan?
Your response must be concise. -7.91. In the year 2012, what is the difference between the Rent(as % of GDP) of Cuba and Rent(as % of GDP) of Ireland?
Your answer should be compact. 0.84. In the year 2012, what is the difference between the Rent(as % of GDP) in Cuba and Rent(as % of GDP) in Tajikistan?
Ensure brevity in your answer.  -0.73. In the year 2012, what is the difference between the Rent(as % of GDP) of Cuba and Rent(as % of GDP) of Uzbekistan?
Keep it short and to the point. -8.12. In the year 2012, what is the difference between the Rent(as % of GDP) of Ireland and Rent(as % of GDP) of Tajikistan?
Provide a succinct answer. -1.57. In the year 2012, what is the difference between the Rent(as % of GDP) in Ireland and Rent(as % of GDP) in Uzbekistan?
Offer a terse response. -8.96. In the year 2012, what is the difference between the Rent(as % of GDP) in Tajikistan and Rent(as % of GDP) in Uzbekistan?
Make the answer very short. -7.39. What is the ratio of the Rent(as % of GDP) in Cuba in 2006 to that in 2007?
Keep it short and to the point. 0.46. What is the ratio of the Rent(as % of GDP) of Ireland in 2006 to that in 2007?
Your response must be concise. 1.22. What is the ratio of the Rent(as % of GDP) in Tajikistan in 2006 to that in 2007?
Keep it short and to the point. 0.98. What is the ratio of the Rent(as % of GDP) in Uzbekistan in 2006 to that in 2007?
Provide a short and direct response. 1.13. What is the ratio of the Rent(as % of GDP) in Cuba in 2006 to that in 2008?
Provide a short and direct response. 1.14. What is the ratio of the Rent(as % of GDP) of Ireland in 2006 to that in 2008?
Your answer should be compact. 6.46. What is the ratio of the Rent(as % of GDP) of Tajikistan in 2006 to that in 2008?
Provide a short and direct response. 1.18. What is the ratio of the Rent(as % of GDP) of Uzbekistan in 2006 to that in 2008?
Offer a very short reply. 1.04. What is the ratio of the Rent(as % of GDP) of Cuba in 2006 to that in 2009?
Ensure brevity in your answer.  2.17. What is the ratio of the Rent(as % of GDP) in Ireland in 2006 to that in 2009?
Give a very brief answer. 10.53. What is the ratio of the Rent(as % of GDP) of Tajikistan in 2006 to that in 2009?
Keep it short and to the point. 1.14. What is the ratio of the Rent(as % of GDP) of Uzbekistan in 2006 to that in 2009?
Provide a succinct answer. 1.15. What is the ratio of the Rent(as % of GDP) of Cuba in 2006 to that in 2010?
Keep it short and to the point. 1.16. What is the ratio of the Rent(as % of GDP) in Ireland in 2006 to that in 2010?
Your answer should be very brief. 3.1. What is the ratio of the Rent(as % of GDP) of Tajikistan in 2006 to that in 2010?
Give a very brief answer. 0.63. What is the ratio of the Rent(as % of GDP) of Uzbekistan in 2006 to that in 2010?
Provide a succinct answer. 0.98. What is the ratio of the Rent(as % of GDP) of Cuba in 2006 to that in 2011?
Your answer should be very brief. 1.16. What is the ratio of the Rent(as % of GDP) of Ireland in 2006 to that in 2011?
Keep it short and to the point. 3.81. What is the ratio of the Rent(as % of GDP) of Tajikistan in 2006 to that in 2011?
Offer a terse response. 0.42. What is the ratio of the Rent(as % of GDP) of Uzbekistan in 2006 to that in 2011?
Give a very brief answer. 0.82. What is the ratio of the Rent(as % of GDP) in Cuba in 2006 to that in 2012?
Provide a short and direct response. 2.72. What is the ratio of the Rent(as % of GDP) in Ireland in 2006 to that in 2012?
Your answer should be compact. 5.78. What is the ratio of the Rent(as % of GDP) in Tajikistan in 2006 to that in 2012?
Keep it short and to the point. 0.4. What is the ratio of the Rent(as % of GDP) of Uzbekistan in 2006 to that in 2012?
Give a very brief answer. 0.86. What is the ratio of the Rent(as % of GDP) of Cuba in 2007 to that in 2008?
Provide a short and direct response. 2.48. What is the ratio of the Rent(as % of GDP) of Ireland in 2007 to that in 2008?
Offer a very short reply. 5.32. What is the ratio of the Rent(as % of GDP) of Tajikistan in 2007 to that in 2008?
Ensure brevity in your answer.  1.21. What is the ratio of the Rent(as % of GDP) in Uzbekistan in 2007 to that in 2008?
Give a very brief answer. 0.93. What is the ratio of the Rent(as % of GDP) in Cuba in 2007 to that in 2009?
Provide a short and direct response. 4.73. What is the ratio of the Rent(as % of GDP) of Ireland in 2007 to that in 2009?
Give a very brief answer. 8.66. What is the ratio of the Rent(as % of GDP) in Tajikistan in 2007 to that in 2009?
Keep it short and to the point. 1.17. What is the ratio of the Rent(as % of GDP) in Uzbekistan in 2007 to that in 2009?
Ensure brevity in your answer.  1.02. What is the ratio of the Rent(as % of GDP) of Cuba in 2007 to that in 2010?
Your response must be concise. 2.53. What is the ratio of the Rent(as % of GDP) of Ireland in 2007 to that in 2010?
Offer a terse response. 2.55. What is the ratio of the Rent(as % of GDP) of Tajikistan in 2007 to that in 2010?
Give a very brief answer. 0.64. What is the ratio of the Rent(as % of GDP) of Uzbekistan in 2007 to that in 2010?
Keep it short and to the point. 0.87. What is the ratio of the Rent(as % of GDP) in Cuba in 2007 to that in 2011?
Your answer should be compact. 2.54. What is the ratio of the Rent(as % of GDP) in Ireland in 2007 to that in 2011?
Keep it short and to the point. 3.13. What is the ratio of the Rent(as % of GDP) of Tajikistan in 2007 to that in 2011?
Give a very brief answer. 0.43. What is the ratio of the Rent(as % of GDP) in Uzbekistan in 2007 to that in 2011?
Ensure brevity in your answer.  0.73. What is the ratio of the Rent(as % of GDP) of Cuba in 2007 to that in 2012?
Offer a very short reply. 5.94. What is the ratio of the Rent(as % of GDP) in Ireland in 2007 to that in 2012?
Keep it short and to the point. 4.76. What is the ratio of the Rent(as % of GDP) in Tajikistan in 2007 to that in 2012?
Your answer should be very brief. 0.41. What is the ratio of the Rent(as % of GDP) in Uzbekistan in 2007 to that in 2012?
Provide a short and direct response. 0.76. What is the ratio of the Rent(as % of GDP) of Cuba in 2008 to that in 2009?
Provide a succinct answer. 1.9. What is the ratio of the Rent(as % of GDP) in Ireland in 2008 to that in 2009?
Your response must be concise. 1.63. What is the ratio of the Rent(as % of GDP) in Tajikistan in 2008 to that in 2009?
Provide a short and direct response. 0.97. What is the ratio of the Rent(as % of GDP) of Uzbekistan in 2008 to that in 2009?
Offer a very short reply. 1.1. What is the ratio of the Rent(as % of GDP) of Cuba in 2008 to that in 2010?
Make the answer very short. 1.02. What is the ratio of the Rent(as % of GDP) in Ireland in 2008 to that in 2010?
Provide a short and direct response. 0.48. What is the ratio of the Rent(as % of GDP) of Tajikistan in 2008 to that in 2010?
Your response must be concise. 0.53. What is the ratio of the Rent(as % of GDP) of Uzbekistan in 2008 to that in 2010?
Give a very brief answer. 0.94. What is the ratio of the Rent(as % of GDP) of Cuba in 2008 to that in 2011?
Your response must be concise. 1.02. What is the ratio of the Rent(as % of GDP) of Ireland in 2008 to that in 2011?
Your answer should be very brief. 0.59. What is the ratio of the Rent(as % of GDP) in Tajikistan in 2008 to that in 2011?
Your response must be concise. 0.35. What is the ratio of the Rent(as % of GDP) of Uzbekistan in 2008 to that in 2011?
Provide a short and direct response. 0.78. What is the ratio of the Rent(as % of GDP) in Cuba in 2008 to that in 2012?
Keep it short and to the point. 2.39. What is the ratio of the Rent(as % of GDP) of Ireland in 2008 to that in 2012?
Give a very brief answer. 0.89. What is the ratio of the Rent(as % of GDP) in Tajikistan in 2008 to that in 2012?
Provide a succinct answer. 0.34. What is the ratio of the Rent(as % of GDP) of Uzbekistan in 2008 to that in 2012?
Provide a short and direct response. 0.83. What is the ratio of the Rent(as % of GDP) of Cuba in 2009 to that in 2010?
Your answer should be compact. 0.54. What is the ratio of the Rent(as % of GDP) of Ireland in 2009 to that in 2010?
Your answer should be compact. 0.29. What is the ratio of the Rent(as % of GDP) of Tajikistan in 2009 to that in 2010?
Your answer should be compact. 0.55. What is the ratio of the Rent(as % of GDP) in Uzbekistan in 2009 to that in 2010?
Ensure brevity in your answer.  0.85. What is the ratio of the Rent(as % of GDP) in Cuba in 2009 to that in 2011?
Keep it short and to the point. 0.54. What is the ratio of the Rent(as % of GDP) of Ireland in 2009 to that in 2011?
Ensure brevity in your answer.  0.36. What is the ratio of the Rent(as % of GDP) of Tajikistan in 2009 to that in 2011?
Your response must be concise. 0.37. What is the ratio of the Rent(as % of GDP) in Uzbekistan in 2009 to that in 2011?
Provide a succinct answer. 0.71. What is the ratio of the Rent(as % of GDP) in Cuba in 2009 to that in 2012?
Offer a terse response. 1.26. What is the ratio of the Rent(as % of GDP) in Ireland in 2009 to that in 2012?
Ensure brevity in your answer.  0.55. What is the ratio of the Rent(as % of GDP) in Tajikistan in 2009 to that in 2012?
Make the answer very short. 0.35. What is the ratio of the Rent(as % of GDP) in Uzbekistan in 2009 to that in 2012?
Make the answer very short. 0.75. What is the ratio of the Rent(as % of GDP) of Cuba in 2010 to that in 2011?
Make the answer very short. 1. What is the ratio of the Rent(as % of GDP) of Ireland in 2010 to that in 2011?
Ensure brevity in your answer.  1.23. What is the ratio of the Rent(as % of GDP) of Tajikistan in 2010 to that in 2011?
Make the answer very short. 0.66. What is the ratio of the Rent(as % of GDP) in Uzbekistan in 2010 to that in 2011?
Ensure brevity in your answer.  0.84. What is the ratio of the Rent(as % of GDP) of Cuba in 2010 to that in 2012?
Your answer should be compact. 2.34. What is the ratio of the Rent(as % of GDP) of Ireland in 2010 to that in 2012?
Keep it short and to the point. 1.86. What is the ratio of the Rent(as % of GDP) of Tajikistan in 2010 to that in 2012?
Provide a short and direct response. 0.64. What is the ratio of the Rent(as % of GDP) of Uzbekistan in 2010 to that in 2012?
Give a very brief answer. 0.88. What is the ratio of the Rent(as % of GDP) in Cuba in 2011 to that in 2012?
Give a very brief answer. 2.34. What is the ratio of the Rent(as % of GDP) in Ireland in 2011 to that in 2012?
Your response must be concise. 1.52. What is the ratio of the Rent(as % of GDP) in Tajikistan in 2011 to that in 2012?
Your response must be concise. 0.97. What is the ratio of the Rent(as % of GDP) of Uzbekistan in 2011 to that in 2012?
Keep it short and to the point. 1.05. What is the difference between the highest and the second highest Rent(as % of GDP) of Cuba?
Your response must be concise. 2.91. What is the difference between the highest and the second highest Rent(as % of GDP) of Ireland?
Your answer should be compact. 0.06. What is the difference between the highest and the second highest Rent(as % of GDP) of Tajikistan?
Make the answer very short. 0.05. What is the difference between the highest and the second highest Rent(as % of GDP) in Uzbekistan?
Provide a short and direct response. 0.47. What is the difference between the highest and the lowest Rent(as % of GDP) in Cuba?
Ensure brevity in your answer.  4.47. What is the difference between the highest and the lowest Rent(as % of GDP) in Ireland?
Make the answer very short. 0.32. What is the difference between the highest and the lowest Rent(as % of GDP) in Tajikistan?
Provide a short and direct response. 1.07. What is the difference between the highest and the lowest Rent(as % of GDP) in Uzbekistan?
Offer a very short reply. 2.71. 